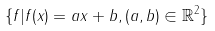Convert formula to latex. <formula><loc_0><loc_0><loc_500><loc_500>\{ f | f ( x ) = a x + b , ( a , b ) \in \mathbb { R } ^ { 2 } \}</formula> 